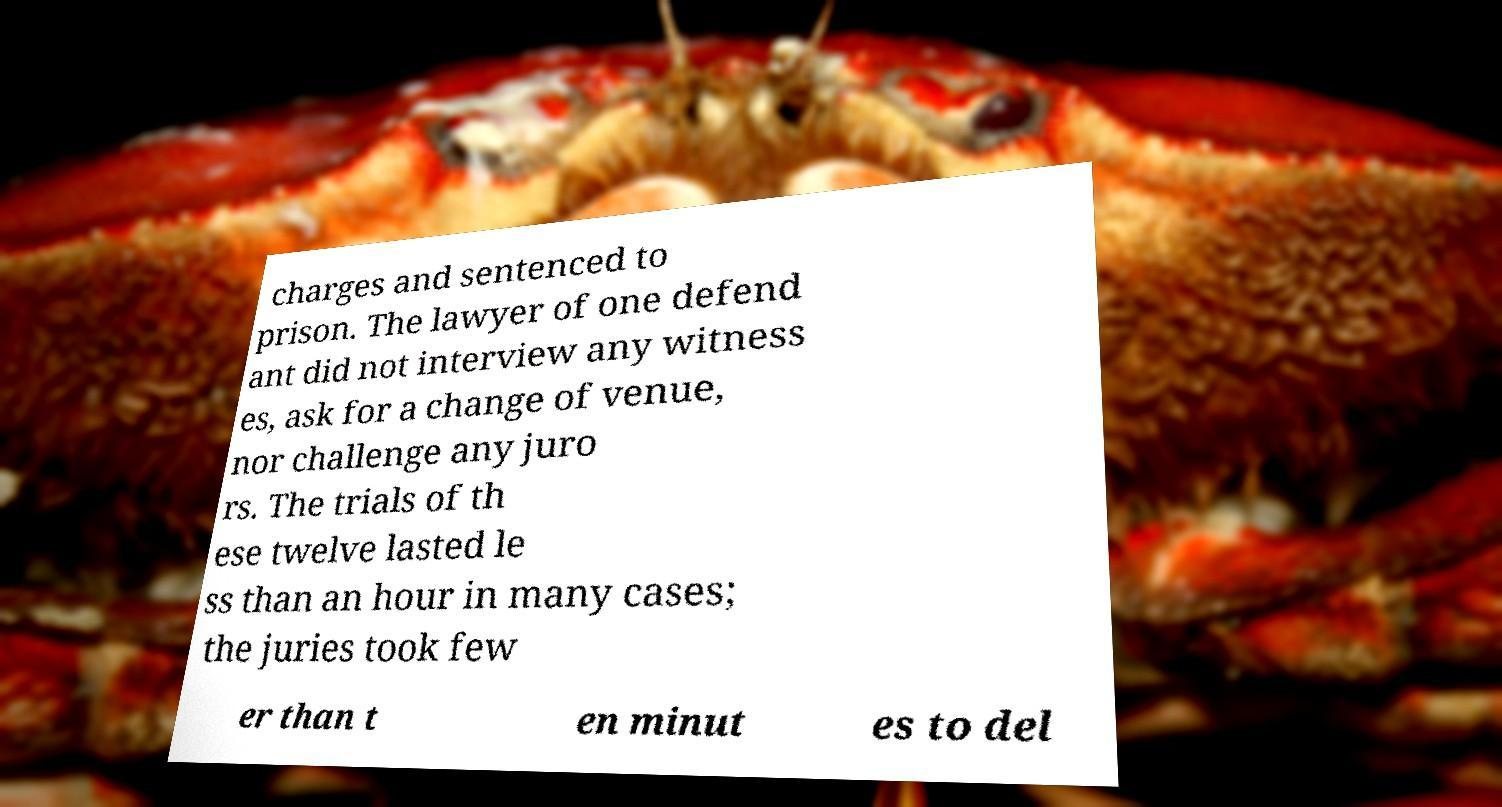Please read and relay the text visible in this image. What does it say? charges and sentenced to prison. The lawyer of one defend ant did not interview any witness es, ask for a change of venue, nor challenge any juro rs. The trials of th ese twelve lasted le ss than an hour in many cases; the juries took few er than t en minut es to del 